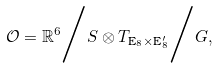Convert formula to latex. <formula><loc_0><loc_0><loc_500><loc_500>\mathcal { O } = \mathbb { R } ^ { 6 } \Big { / } S \otimes T _ { \text {E} _ { 8 } \times \text {E} _ { 8 } ^ { \prime } } \Big { / } G ,</formula> 